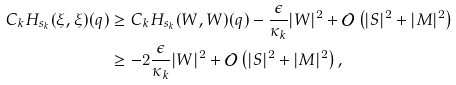<formula> <loc_0><loc_0><loc_500><loc_500>C _ { k } H _ { s _ { k } } ( \xi , \xi ) ( q ) & \geq C _ { k } H _ { s _ { k } } ( W , W ) ( q ) - \frac { \epsilon } { \kappa _ { k } } | W | ^ { 2 } + \mathcal { O } \left ( | S | ^ { 2 } + | M | ^ { 2 } \right ) \\ & \geq - 2 \frac { \epsilon } { \kappa _ { k } } | W | ^ { 2 } + \mathcal { O } \left ( | S | ^ { 2 } + | M | ^ { 2 } \right ) ,</formula> 